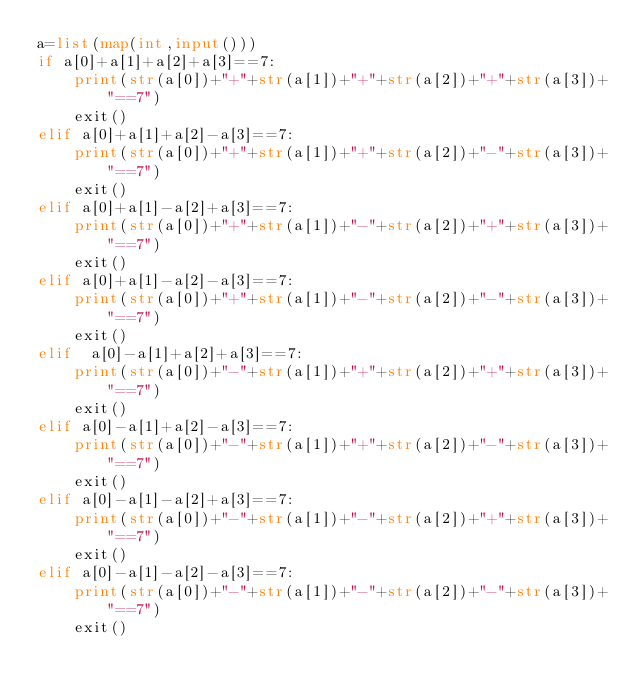<code> <loc_0><loc_0><loc_500><loc_500><_Python_>a=list(map(int,input()))
if a[0]+a[1]+a[2]+a[3]==7:
    print(str(a[0])+"+"+str(a[1])+"+"+str(a[2])+"+"+str(a[3])+"==7")
    exit()
elif a[0]+a[1]+a[2]-a[3]==7:
    print(str(a[0])+"+"+str(a[1])+"+"+str(a[2])+"-"+str(a[3])+"==7")
    exit()
elif a[0]+a[1]-a[2]+a[3]==7:
    print(str(a[0])+"+"+str(a[1])+"-"+str(a[2])+"+"+str(a[3])+"==7")
    exit()
elif a[0]+a[1]-a[2]-a[3]==7:
    print(str(a[0])+"+"+str(a[1])+"-"+str(a[2])+"-"+str(a[3])+"==7")
    exit()
elif  a[0]-a[1]+a[2]+a[3]==7:
    print(str(a[0])+"-"+str(a[1])+"+"+str(a[2])+"+"+str(a[3])+"==7")
    exit()
elif a[0]-a[1]+a[2]-a[3]==7:
    print(str(a[0])+"-"+str(a[1])+"+"+str(a[2])+"-"+str(a[3])+"==7")
    exit()
elif a[0]-a[1]-a[2]+a[3]==7:
    print(str(a[0])+"-"+str(a[1])+"-"+str(a[2])+"+"+str(a[3])+"==7")
    exit()
elif a[0]-a[1]-a[2]-a[3]==7:
    print(str(a[0])+"-"+str(a[1])+"-"+str(a[2])+"-"+str(a[3])+"==7")
    exit()
</code> 